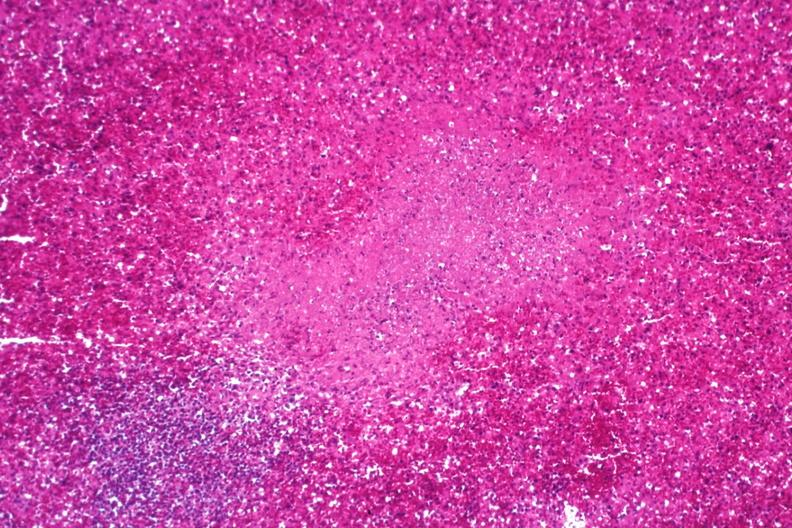s miliary tuberculosis present?
Answer the question using a single word or phrase. Yes 